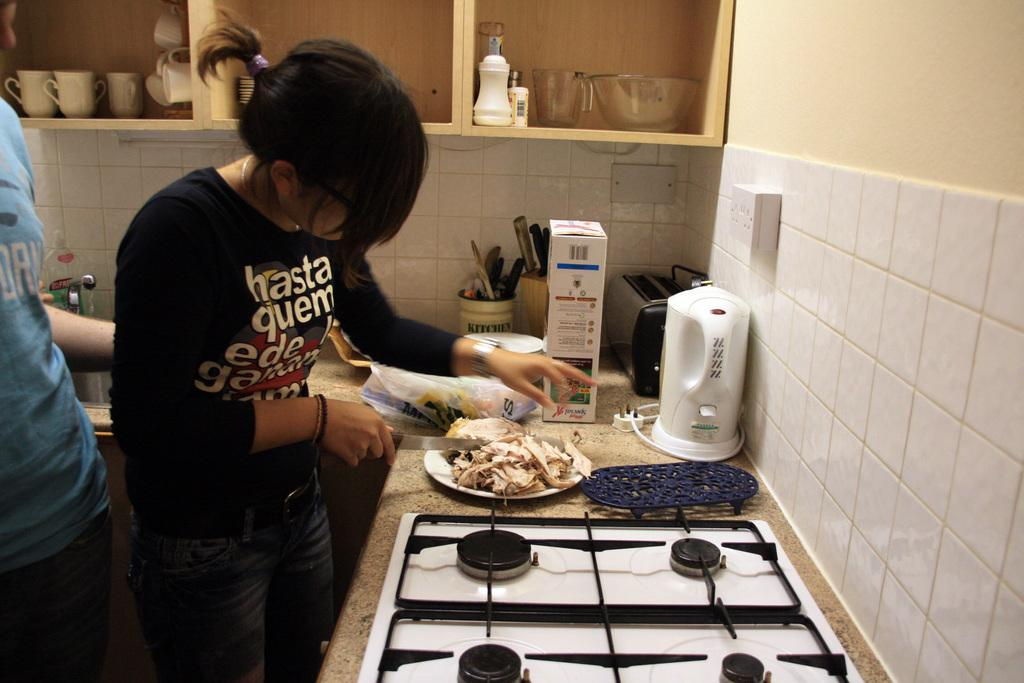<image>
Create a compact narrative representing the image presented. A woman is cutting chicken while wearing a shirt that says hasta quem 